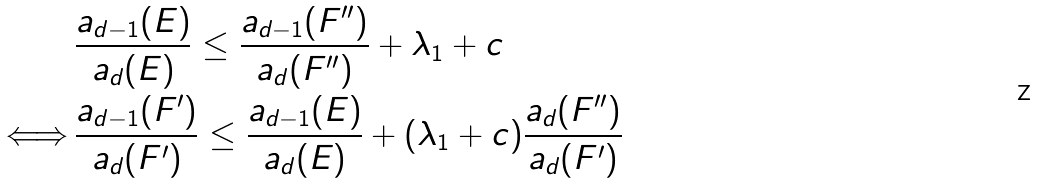<formula> <loc_0><loc_0><loc_500><loc_500>& \frac { a _ { d - 1 } ( E ) } { a _ { d } ( E ) } \leq \frac { a _ { d - 1 } ( F ^ { \prime \prime } ) } { a _ { d } ( F ^ { \prime \prime } ) } + \lambda _ { 1 } + c \\ \Longleftrightarrow \, & \frac { a _ { d - 1 } ( F ^ { \prime } ) } { a _ { d } ( F ^ { \prime } ) } \leq \frac { a _ { d - 1 } ( E ) } { a _ { d } ( E ) } + ( \lambda _ { 1 } + c ) \frac { a _ { d } ( F ^ { \prime \prime } ) } { a _ { d } ( F ^ { \prime } ) }</formula> 